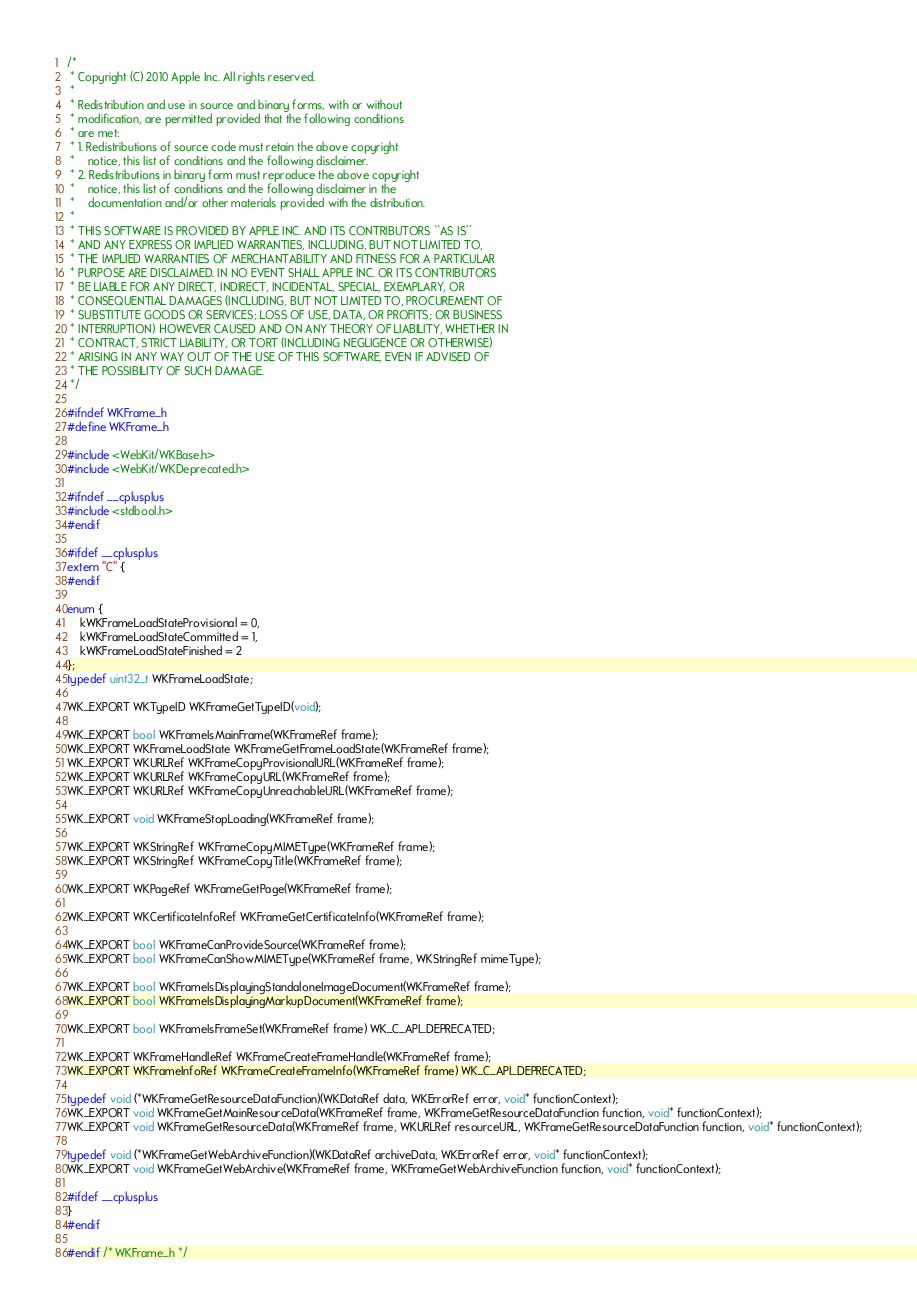Convert code to text. <code><loc_0><loc_0><loc_500><loc_500><_C_>/*
 * Copyright (C) 2010 Apple Inc. All rights reserved.
 *
 * Redistribution and use in source and binary forms, with or without
 * modification, are permitted provided that the following conditions
 * are met:
 * 1. Redistributions of source code must retain the above copyright
 *    notice, this list of conditions and the following disclaimer.
 * 2. Redistributions in binary form must reproduce the above copyright
 *    notice, this list of conditions and the following disclaimer in the
 *    documentation and/or other materials provided with the distribution.
 *
 * THIS SOFTWARE IS PROVIDED BY APPLE INC. AND ITS CONTRIBUTORS ``AS IS''
 * AND ANY EXPRESS OR IMPLIED WARRANTIES, INCLUDING, BUT NOT LIMITED TO,
 * THE IMPLIED WARRANTIES OF MERCHANTABILITY AND FITNESS FOR A PARTICULAR
 * PURPOSE ARE DISCLAIMED. IN NO EVENT SHALL APPLE INC. OR ITS CONTRIBUTORS
 * BE LIABLE FOR ANY DIRECT, INDIRECT, INCIDENTAL, SPECIAL, EXEMPLARY, OR
 * CONSEQUENTIAL DAMAGES (INCLUDING, BUT NOT LIMITED TO, PROCUREMENT OF
 * SUBSTITUTE GOODS OR SERVICES; LOSS OF USE, DATA, OR PROFITS; OR BUSINESS
 * INTERRUPTION) HOWEVER CAUSED AND ON ANY THEORY OF LIABILITY, WHETHER IN
 * CONTRACT, STRICT LIABILITY, OR TORT (INCLUDING NEGLIGENCE OR OTHERWISE)
 * ARISING IN ANY WAY OUT OF THE USE OF THIS SOFTWARE, EVEN IF ADVISED OF
 * THE POSSIBILITY OF SUCH DAMAGE.
 */

#ifndef WKFrame_h
#define WKFrame_h

#include <WebKit/WKBase.h>
#include <WebKit/WKDeprecated.h>

#ifndef __cplusplus
#include <stdbool.h>
#endif

#ifdef __cplusplus
extern "C" {
#endif

enum {
    kWKFrameLoadStateProvisional = 0,
    kWKFrameLoadStateCommitted = 1,
    kWKFrameLoadStateFinished = 2
};
typedef uint32_t WKFrameLoadState;

WK_EXPORT WKTypeID WKFrameGetTypeID(void);
 
WK_EXPORT bool WKFrameIsMainFrame(WKFrameRef frame);
WK_EXPORT WKFrameLoadState WKFrameGetFrameLoadState(WKFrameRef frame);
WK_EXPORT WKURLRef WKFrameCopyProvisionalURL(WKFrameRef frame);
WK_EXPORT WKURLRef WKFrameCopyURL(WKFrameRef frame);
WK_EXPORT WKURLRef WKFrameCopyUnreachableURL(WKFrameRef frame);

WK_EXPORT void WKFrameStopLoading(WKFrameRef frame);

WK_EXPORT WKStringRef WKFrameCopyMIMEType(WKFrameRef frame);
WK_EXPORT WKStringRef WKFrameCopyTitle(WKFrameRef frame);

WK_EXPORT WKPageRef WKFrameGetPage(WKFrameRef frame);

WK_EXPORT WKCertificateInfoRef WKFrameGetCertificateInfo(WKFrameRef frame);

WK_EXPORT bool WKFrameCanProvideSource(WKFrameRef frame);
WK_EXPORT bool WKFrameCanShowMIMEType(WKFrameRef frame, WKStringRef mimeType);

WK_EXPORT bool WKFrameIsDisplayingStandaloneImageDocument(WKFrameRef frame);
WK_EXPORT bool WKFrameIsDisplayingMarkupDocument(WKFrameRef frame);

WK_EXPORT bool WKFrameIsFrameSet(WKFrameRef frame) WK_C_API_DEPRECATED;

WK_EXPORT WKFrameHandleRef WKFrameCreateFrameHandle(WKFrameRef frame);
WK_EXPORT WKFrameInfoRef WKFrameCreateFrameInfo(WKFrameRef frame) WK_C_API_DEPRECATED;

typedef void (*WKFrameGetResourceDataFunction)(WKDataRef data, WKErrorRef error, void* functionContext);
WK_EXPORT void WKFrameGetMainResourceData(WKFrameRef frame, WKFrameGetResourceDataFunction function, void* functionContext);
WK_EXPORT void WKFrameGetResourceData(WKFrameRef frame, WKURLRef resourceURL, WKFrameGetResourceDataFunction function, void* functionContext);

typedef void (*WKFrameGetWebArchiveFunction)(WKDataRef archiveData, WKErrorRef error, void* functionContext);
WK_EXPORT void WKFrameGetWebArchive(WKFrameRef frame, WKFrameGetWebArchiveFunction function, void* functionContext);

#ifdef __cplusplus
}
#endif

#endif /* WKFrame_h */
</code> 